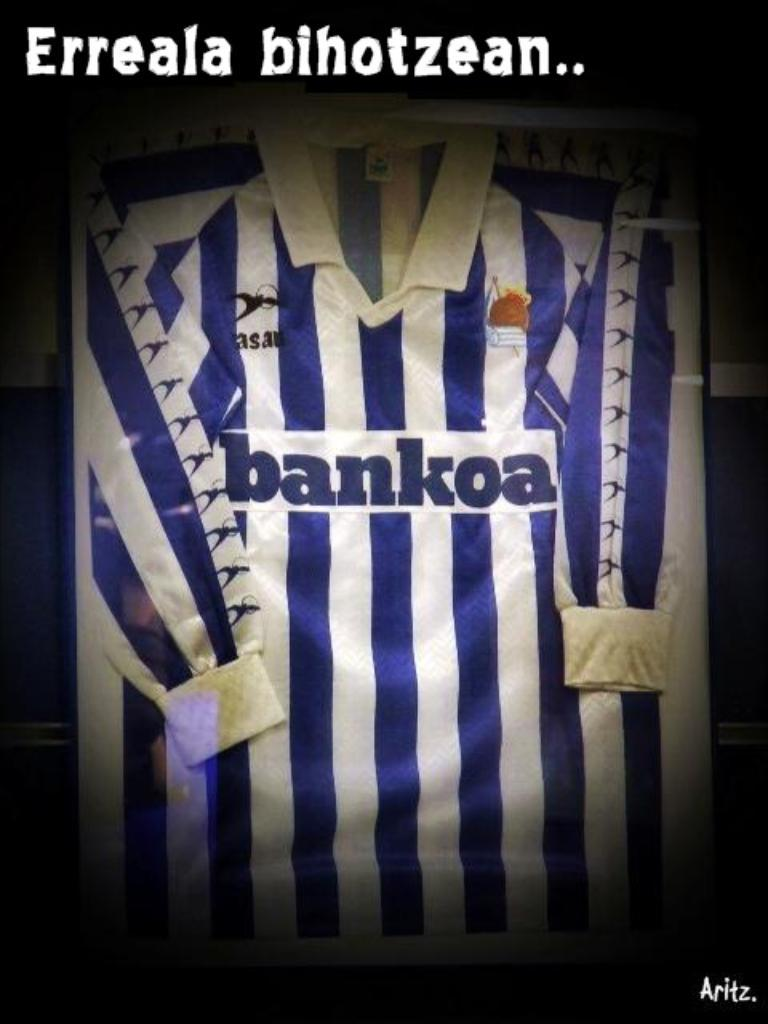<image>
Write a terse but informative summary of the picture. A blue and whtie striped long sleeved Bankoa jersey. 